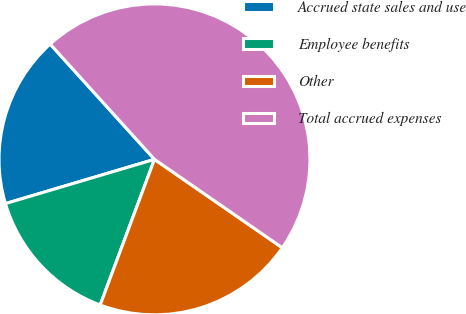<chart> <loc_0><loc_0><loc_500><loc_500><pie_chart><fcel>Accrued state sales and use<fcel>Employee benefits<fcel>Other<fcel>Total accrued expenses<nl><fcel>17.89%<fcel>14.73%<fcel>21.05%<fcel>46.34%<nl></chart> 